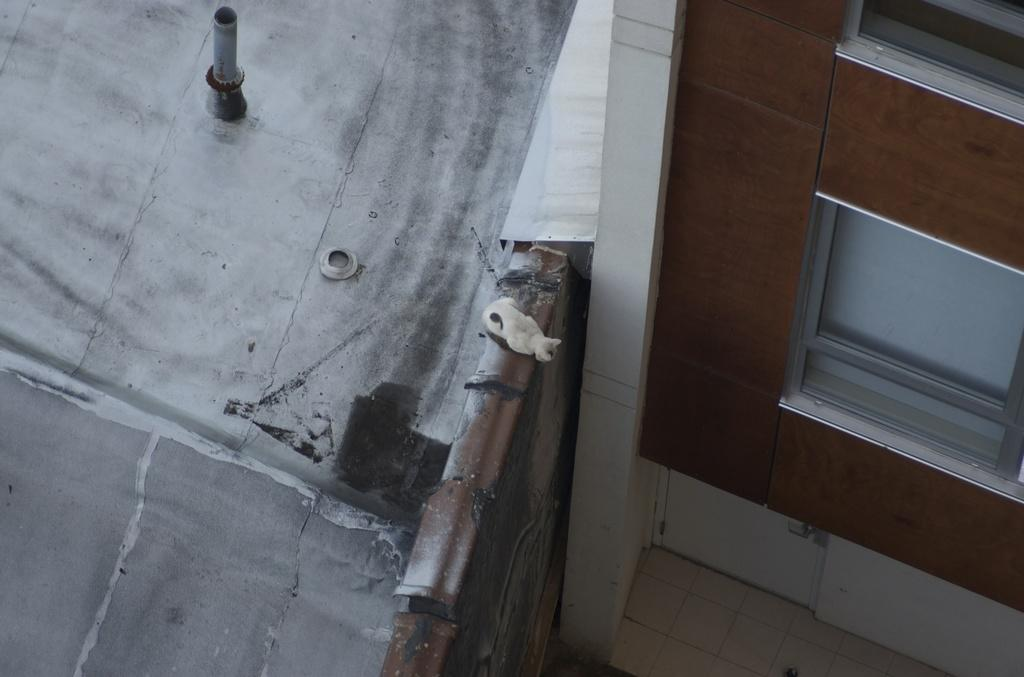What is attached to the wall in the image? There is an object attached to the wall in the image, but the specific object is not mentioned in the facts. Can you describe any other objects present in the image? Yes, there are other objects present in the image, but their specific details are not mentioned in the facts. What type of prison is depicted in the image? There is no prison present in the image. How many lifts can be seen in the image? There is no lift present in the image. 